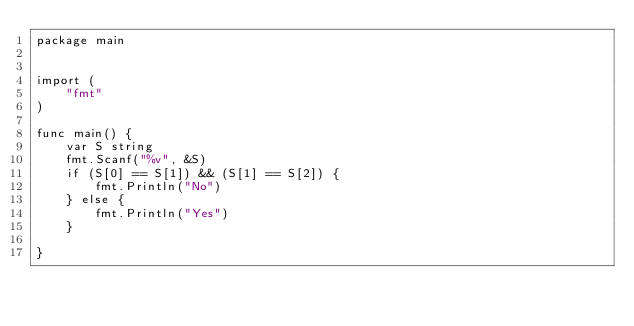Convert code to text. <code><loc_0><loc_0><loc_500><loc_500><_Go_>package main


import (
	"fmt"
)

func main() {
	var S string
	fmt.Scanf("%v", &S)
	if (S[0] == S[1]) && (S[1] == S[2]) {
		fmt.Println("No")
	} else {
		fmt.Println("Yes")
	}

}
</code> 